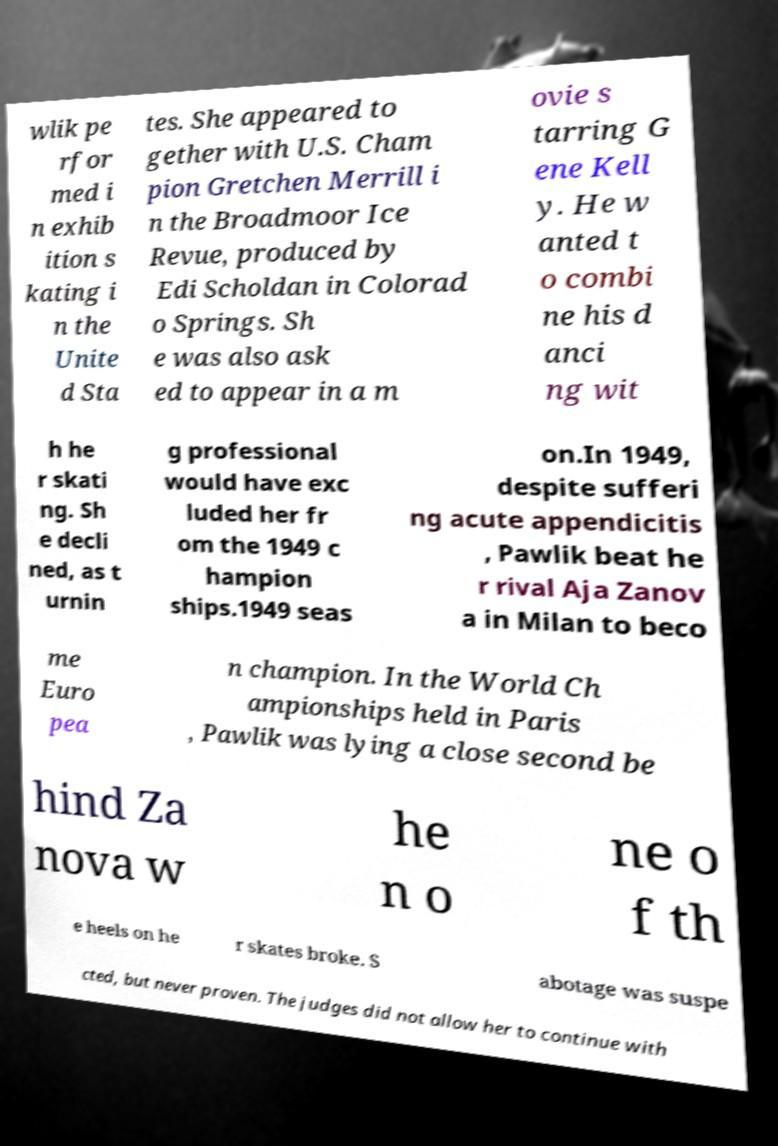There's text embedded in this image that I need extracted. Can you transcribe it verbatim? wlik pe rfor med i n exhib ition s kating i n the Unite d Sta tes. She appeared to gether with U.S. Cham pion Gretchen Merrill i n the Broadmoor Ice Revue, produced by Edi Scholdan in Colorad o Springs. Sh e was also ask ed to appear in a m ovie s tarring G ene Kell y. He w anted t o combi ne his d anci ng wit h he r skati ng. Sh e decli ned, as t urnin g professional would have exc luded her fr om the 1949 c hampion ships.1949 seas on.In 1949, despite sufferi ng acute appendicitis , Pawlik beat he r rival Aja Zanov a in Milan to beco me Euro pea n champion. In the World Ch ampionships held in Paris , Pawlik was lying a close second be hind Za nova w he n o ne o f th e heels on he r skates broke. S abotage was suspe cted, but never proven. The judges did not allow her to continue with 